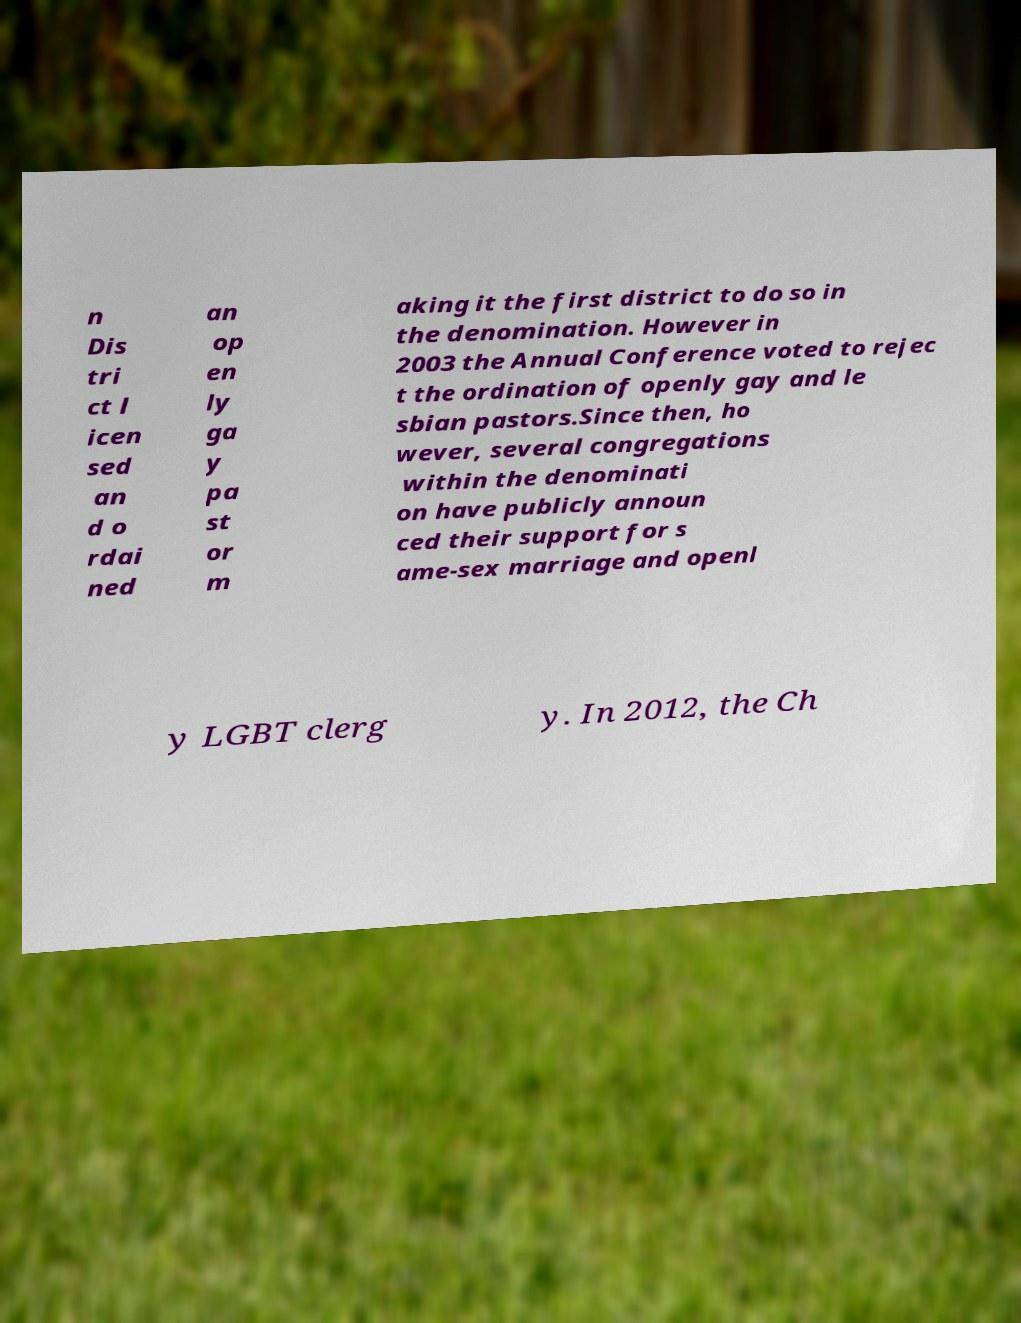Could you extract and type out the text from this image? n Dis tri ct l icen sed an d o rdai ned an op en ly ga y pa st or m aking it the first district to do so in the denomination. However in 2003 the Annual Conference voted to rejec t the ordination of openly gay and le sbian pastors.Since then, ho wever, several congregations within the denominati on have publicly announ ced their support for s ame-sex marriage and openl y LGBT clerg y. In 2012, the Ch 